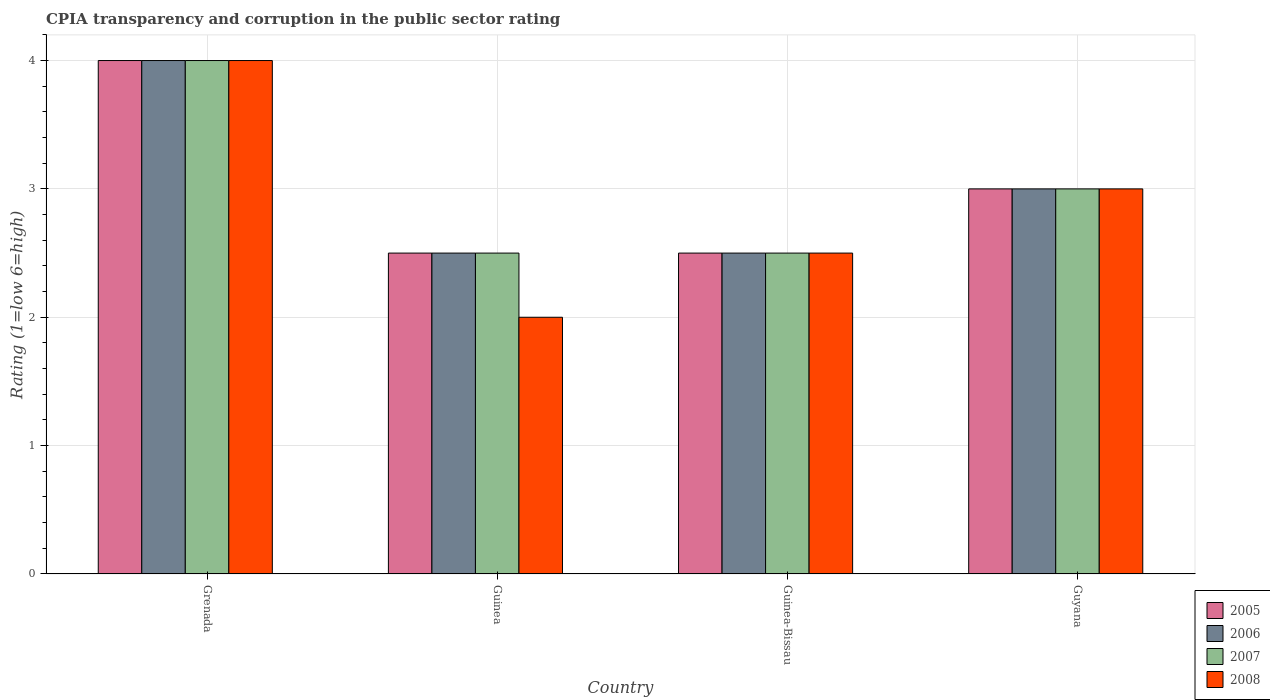How many groups of bars are there?
Your response must be concise. 4. Are the number of bars per tick equal to the number of legend labels?
Offer a very short reply. Yes. How many bars are there on the 2nd tick from the left?
Your answer should be compact. 4. What is the label of the 1st group of bars from the left?
Your answer should be compact. Grenada. Across all countries, what is the maximum CPIA rating in 2006?
Provide a short and direct response. 4. In which country was the CPIA rating in 2005 maximum?
Provide a short and direct response. Grenada. In which country was the CPIA rating in 2006 minimum?
Your response must be concise. Guinea. What is the total CPIA rating in 2005 in the graph?
Provide a succinct answer. 12. What is the ratio of the CPIA rating in 2005 in Grenada to that in Guinea?
Give a very brief answer. 1.6. Is the CPIA rating in 2007 in Grenada less than that in Guyana?
Your response must be concise. No. Is the difference between the CPIA rating in 2006 in Guinea-Bissau and Guyana greater than the difference between the CPIA rating in 2008 in Guinea-Bissau and Guyana?
Provide a short and direct response. No. What is the difference between the highest and the second highest CPIA rating in 2005?
Provide a short and direct response. -0.5. Is the sum of the CPIA rating in 2005 in Guinea and Guyana greater than the maximum CPIA rating in 2008 across all countries?
Offer a terse response. Yes. What does the 1st bar from the left in Guyana represents?
Keep it short and to the point. 2005. What does the 2nd bar from the right in Guinea represents?
Your answer should be very brief. 2007. Is it the case that in every country, the sum of the CPIA rating in 2007 and CPIA rating in 2008 is greater than the CPIA rating in 2006?
Give a very brief answer. Yes. How many bars are there?
Make the answer very short. 16. Are all the bars in the graph horizontal?
Keep it short and to the point. No. How many countries are there in the graph?
Your answer should be very brief. 4. What is the difference between two consecutive major ticks on the Y-axis?
Offer a terse response. 1. Are the values on the major ticks of Y-axis written in scientific E-notation?
Make the answer very short. No. How are the legend labels stacked?
Keep it short and to the point. Vertical. What is the title of the graph?
Keep it short and to the point. CPIA transparency and corruption in the public sector rating. Does "1969" appear as one of the legend labels in the graph?
Give a very brief answer. No. What is the label or title of the X-axis?
Your answer should be very brief. Country. What is the Rating (1=low 6=high) in 2007 in Grenada?
Give a very brief answer. 4. What is the Rating (1=low 6=high) in 2008 in Grenada?
Provide a succinct answer. 4. What is the Rating (1=low 6=high) in 2005 in Guinea?
Keep it short and to the point. 2.5. What is the Rating (1=low 6=high) of 2007 in Guinea?
Offer a very short reply. 2.5. What is the Rating (1=low 6=high) of 2005 in Guinea-Bissau?
Offer a very short reply. 2.5. What is the Rating (1=low 6=high) of 2006 in Guinea-Bissau?
Give a very brief answer. 2.5. What is the Rating (1=low 6=high) of 2007 in Guinea-Bissau?
Give a very brief answer. 2.5. What is the Rating (1=low 6=high) of 2008 in Guinea-Bissau?
Your answer should be very brief. 2.5. What is the Rating (1=low 6=high) in 2005 in Guyana?
Offer a very short reply. 3. What is the Rating (1=low 6=high) of 2006 in Guyana?
Ensure brevity in your answer.  3. What is the Rating (1=low 6=high) of 2007 in Guyana?
Offer a very short reply. 3. What is the Rating (1=low 6=high) of 2008 in Guyana?
Your response must be concise. 3. Across all countries, what is the minimum Rating (1=low 6=high) of 2005?
Your answer should be compact. 2.5. Across all countries, what is the minimum Rating (1=low 6=high) in 2006?
Your answer should be very brief. 2.5. Across all countries, what is the minimum Rating (1=low 6=high) in 2007?
Make the answer very short. 2.5. What is the total Rating (1=low 6=high) of 2005 in the graph?
Keep it short and to the point. 12. What is the total Rating (1=low 6=high) of 2006 in the graph?
Provide a succinct answer. 12. What is the total Rating (1=low 6=high) of 2008 in the graph?
Your answer should be very brief. 11.5. What is the difference between the Rating (1=low 6=high) in 2007 in Grenada and that in Guinea?
Your answer should be very brief. 1.5. What is the difference between the Rating (1=low 6=high) of 2008 in Grenada and that in Guinea?
Give a very brief answer. 2. What is the difference between the Rating (1=low 6=high) of 2005 in Grenada and that in Guinea-Bissau?
Your answer should be very brief. 1.5. What is the difference between the Rating (1=low 6=high) of 2006 in Grenada and that in Guinea-Bissau?
Make the answer very short. 1.5. What is the difference between the Rating (1=low 6=high) of 2008 in Grenada and that in Guinea-Bissau?
Your answer should be compact. 1.5. What is the difference between the Rating (1=low 6=high) in 2007 in Grenada and that in Guyana?
Give a very brief answer. 1. What is the difference between the Rating (1=low 6=high) of 2005 in Guinea and that in Guinea-Bissau?
Ensure brevity in your answer.  0. What is the difference between the Rating (1=low 6=high) of 2006 in Guinea and that in Guinea-Bissau?
Give a very brief answer. 0. What is the difference between the Rating (1=low 6=high) of 2008 in Guinea and that in Guinea-Bissau?
Provide a short and direct response. -0.5. What is the difference between the Rating (1=low 6=high) of 2005 in Guinea and that in Guyana?
Provide a short and direct response. -0.5. What is the difference between the Rating (1=low 6=high) in 2006 in Guinea and that in Guyana?
Make the answer very short. -0.5. What is the difference between the Rating (1=low 6=high) in 2007 in Guinea and that in Guyana?
Offer a terse response. -0.5. What is the difference between the Rating (1=low 6=high) of 2008 in Guinea and that in Guyana?
Ensure brevity in your answer.  -1. What is the difference between the Rating (1=low 6=high) in 2006 in Guinea-Bissau and that in Guyana?
Keep it short and to the point. -0.5. What is the difference between the Rating (1=low 6=high) in 2008 in Guinea-Bissau and that in Guyana?
Keep it short and to the point. -0.5. What is the difference between the Rating (1=low 6=high) of 2005 in Grenada and the Rating (1=low 6=high) of 2007 in Guinea?
Your answer should be very brief. 1.5. What is the difference between the Rating (1=low 6=high) of 2005 in Grenada and the Rating (1=low 6=high) of 2008 in Guinea?
Give a very brief answer. 2. What is the difference between the Rating (1=low 6=high) in 2006 in Grenada and the Rating (1=low 6=high) in 2007 in Guinea?
Provide a succinct answer. 1.5. What is the difference between the Rating (1=low 6=high) in 2006 in Grenada and the Rating (1=low 6=high) in 2008 in Guinea?
Your answer should be very brief. 2. What is the difference between the Rating (1=low 6=high) of 2005 in Grenada and the Rating (1=low 6=high) of 2007 in Guinea-Bissau?
Your response must be concise. 1.5. What is the difference between the Rating (1=low 6=high) of 2006 in Grenada and the Rating (1=low 6=high) of 2008 in Guinea-Bissau?
Offer a terse response. 1.5. What is the difference between the Rating (1=low 6=high) of 2007 in Grenada and the Rating (1=low 6=high) of 2008 in Guinea-Bissau?
Provide a short and direct response. 1.5. What is the difference between the Rating (1=low 6=high) of 2005 in Grenada and the Rating (1=low 6=high) of 2007 in Guyana?
Keep it short and to the point. 1. What is the difference between the Rating (1=low 6=high) in 2005 in Grenada and the Rating (1=low 6=high) in 2008 in Guyana?
Your response must be concise. 1. What is the difference between the Rating (1=low 6=high) in 2005 in Guinea and the Rating (1=low 6=high) in 2006 in Guinea-Bissau?
Your answer should be very brief. 0. What is the difference between the Rating (1=low 6=high) in 2005 in Guinea and the Rating (1=low 6=high) in 2007 in Guinea-Bissau?
Ensure brevity in your answer.  0. What is the difference between the Rating (1=low 6=high) in 2006 in Guinea and the Rating (1=low 6=high) in 2008 in Guinea-Bissau?
Offer a very short reply. 0. What is the difference between the Rating (1=low 6=high) of 2007 in Guinea and the Rating (1=low 6=high) of 2008 in Guinea-Bissau?
Your answer should be very brief. 0. What is the difference between the Rating (1=low 6=high) of 2005 in Guinea and the Rating (1=low 6=high) of 2006 in Guyana?
Offer a terse response. -0.5. What is the difference between the Rating (1=low 6=high) in 2006 in Guinea and the Rating (1=low 6=high) in 2007 in Guyana?
Your answer should be compact. -0.5. What is the difference between the Rating (1=low 6=high) in 2006 in Guinea and the Rating (1=low 6=high) in 2008 in Guyana?
Make the answer very short. -0.5. What is the difference between the Rating (1=low 6=high) of 2007 in Guinea and the Rating (1=low 6=high) of 2008 in Guyana?
Give a very brief answer. -0.5. What is the difference between the Rating (1=low 6=high) in 2005 in Guinea-Bissau and the Rating (1=low 6=high) in 2007 in Guyana?
Your answer should be very brief. -0.5. What is the difference between the Rating (1=low 6=high) of 2005 in Guinea-Bissau and the Rating (1=low 6=high) of 2008 in Guyana?
Offer a very short reply. -0.5. What is the difference between the Rating (1=low 6=high) in 2007 in Guinea-Bissau and the Rating (1=low 6=high) in 2008 in Guyana?
Provide a succinct answer. -0.5. What is the average Rating (1=low 6=high) in 2008 per country?
Make the answer very short. 2.88. What is the difference between the Rating (1=low 6=high) of 2005 and Rating (1=low 6=high) of 2006 in Grenada?
Ensure brevity in your answer.  0. What is the difference between the Rating (1=low 6=high) in 2005 and Rating (1=low 6=high) in 2007 in Grenada?
Give a very brief answer. 0. What is the difference between the Rating (1=low 6=high) in 2006 and Rating (1=low 6=high) in 2007 in Grenada?
Make the answer very short. 0. What is the difference between the Rating (1=low 6=high) of 2005 and Rating (1=low 6=high) of 2008 in Guinea?
Offer a terse response. 0.5. What is the difference between the Rating (1=low 6=high) of 2005 and Rating (1=low 6=high) of 2006 in Guinea-Bissau?
Offer a very short reply. 0. What is the difference between the Rating (1=low 6=high) in 2005 and Rating (1=low 6=high) in 2007 in Guinea-Bissau?
Offer a very short reply. 0. What is the difference between the Rating (1=low 6=high) of 2006 and Rating (1=low 6=high) of 2007 in Guinea-Bissau?
Keep it short and to the point. 0. What is the difference between the Rating (1=low 6=high) in 2006 and Rating (1=low 6=high) in 2008 in Guinea-Bissau?
Offer a terse response. 0. What is the difference between the Rating (1=low 6=high) in 2005 and Rating (1=low 6=high) in 2007 in Guyana?
Keep it short and to the point. 0. What is the difference between the Rating (1=low 6=high) of 2005 and Rating (1=low 6=high) of 2008 in Guyana?
Provide a short and direct response. 0. What is the difference between the Rating (1=low 6=high) in 2006 and Rating (1=low 6=high) in 2007 in Guyana?
Provide a short and direct response. 0. What is the difference between the Rating (1=low 6=high) in 2006 and Rating (1=low 6=high) in 2008 in Guyana?
Your answer should be compact. 0. What is the difference between the Rating (1=low 6=high) of 2007 and Rating (1=low 6=high) of 2008 in Guyana?
Give a very brief answer. 0. What is the ratio of the Rating (1=low 6=high) of 2005 in Grenada to that in Guinea?
Your response must be concise. 1.6. What is the ratio of the Rating (1=low 6=high) in 2007 in Grenada to that in Guinea?
Your answer should be very brief. 1.6. What is the ratio of the Rating (1=low 6=high) in 2008 in Grenada to that in Guinea?
Keep it short and to the point. 2. What is the ratio of the Rating (1=low 6=high) of 2005 in Grenada to that in Guinea-Bissau?
Provide a short and direct response. 1.6. What is the ratio of the Rating (1=low 6=high) in 2005 in Guinea to that in Guinea-Bissau?
Make the answer very short. 1. What is the ratio of the Rating (1=low 6=high) in 2005 in Guinea to that in Guyana?
Give a very brief answer. 0.83. What is the ratio of the Rating (1=low 6=high) in 2006 in Guinea to that in Guyana?
Keep it short and to the point. 0.83. What is the ratio of the Rating (1=low 6=high) of 2006 in Guinea-Bissau to that in Guyana?
Provide a short and direct response. 0.83. What is the ratio of the Rating (1=low 6=high) in 2008 in Guinea-Bissau to that in Guyana?
Your answer should be compact. 0.83. What is the difference between the highest and the second highest Rating (1=low 6=high) of 2005?
Offer a terse response. 1. What is the difference between the highest and the second highest Rating (1=low 6=high) of 2006?
Offer a very short reply. 1. What is the difference between the highest and the second highest Rating (1=low 6=high) of 2007?
Give a very brief answer. 1. What is the difference between the highest and the lowest Rating (1=low 6=high) in 2008?
Keep it short and to the point. 2. 